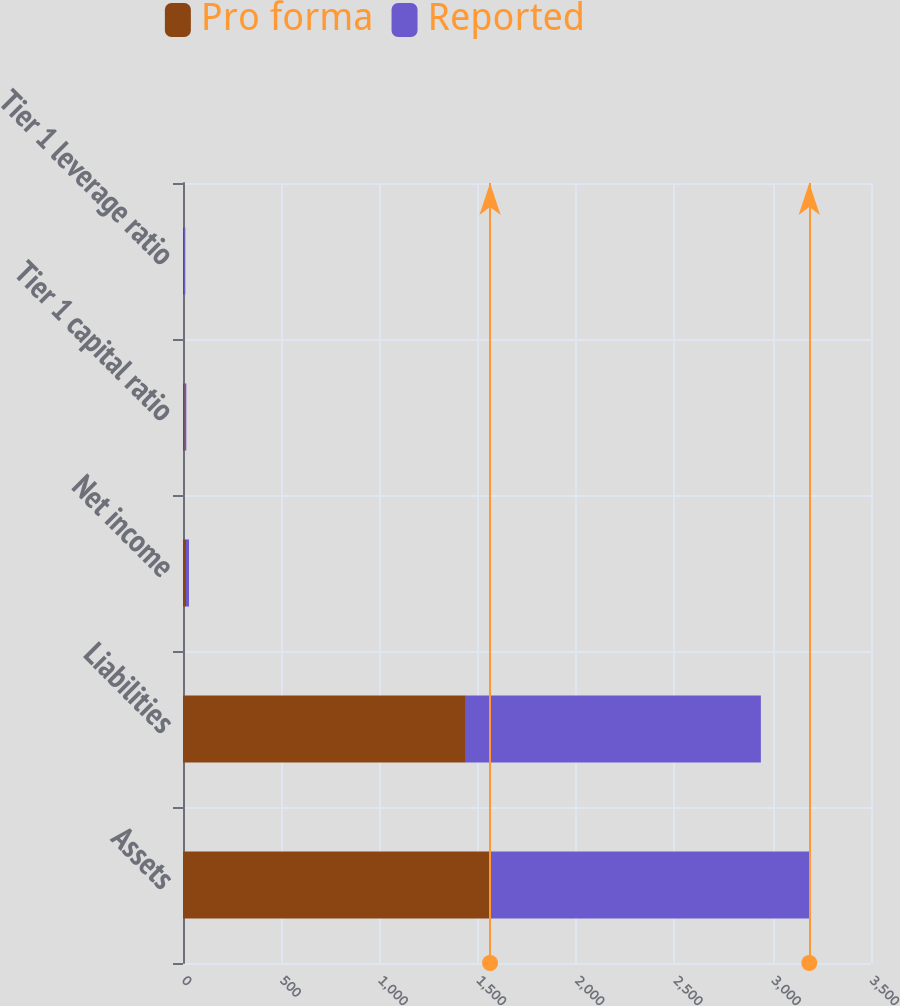<chart> <loc_0><loc_0><loc_500><loc_500><stacked_bar_chart><ecel><fcel>Assets<fcel>Liabilities<fcel>Net income<fcel>Tier 1 capital ratio<fcel>Tier 1 leverage ratio<nl><fcel>Pro forma<fcel>1562.1<fcel>1438.9<fcel>15.4<fcel>8.4<fcel>6<nl><fcel>Reported<fcel>1623.9<fcel>1500.9<fcel>15.2<fcel>8.4<fcel>5.8<nl></chart> 